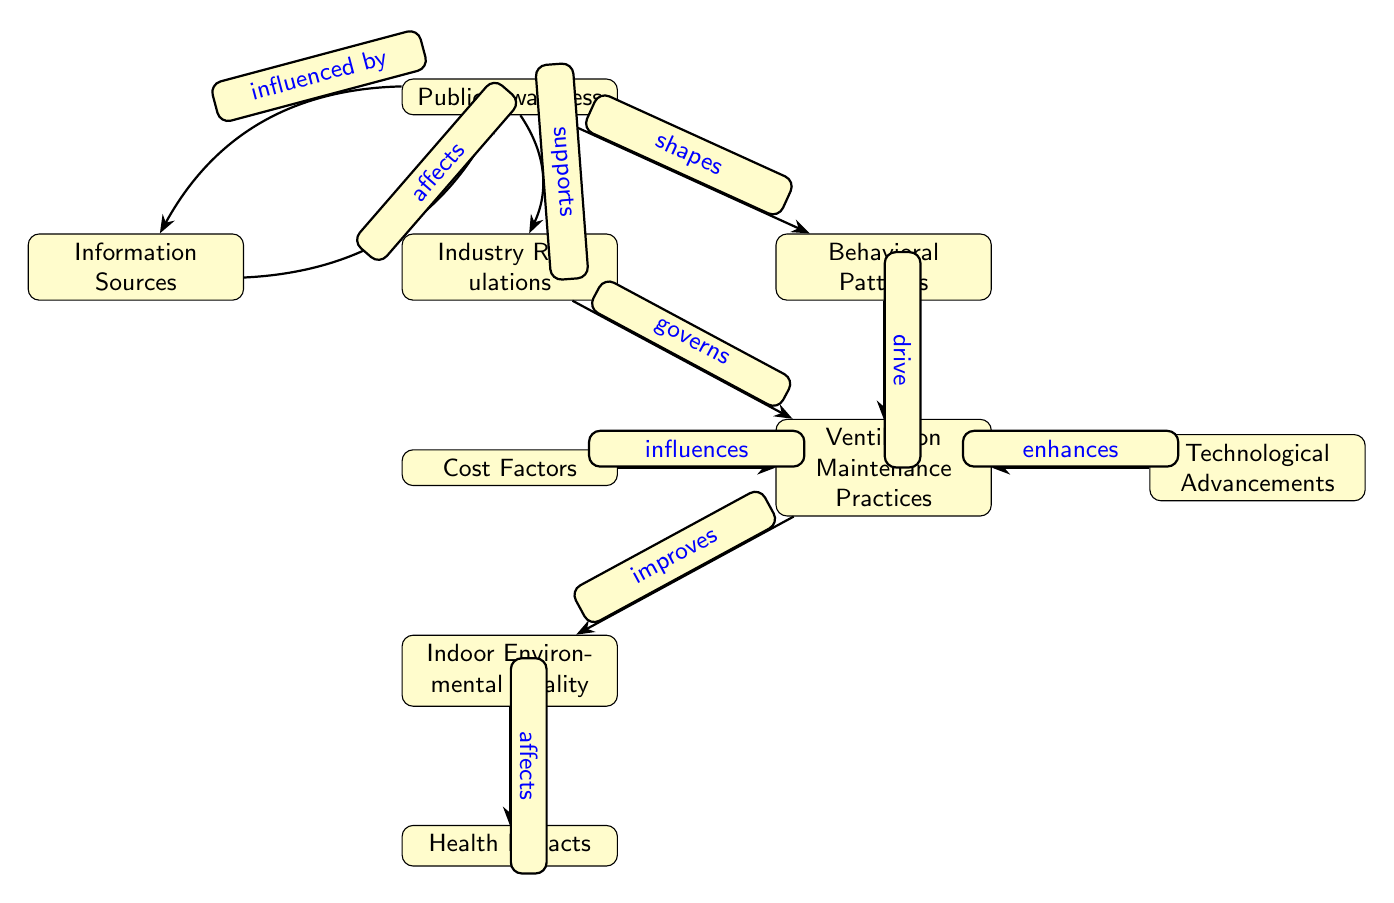What are the two main components that influence Public Awareness? The two main components influencing Public Awareness in the diagram are Information Sources and Industry Regulations. Public Awareness is connected to both these nodes through directed edges indicating influence.
Answer: Information Sources, Industry Regulations How many nodes are depicted in the diagram? The diagram consists of 8 distinct nodes. These nodes represent different concepts related to ventilation maintenance practices and their implications for indoor environmental quality.
Answer: 8 What effect do Behavioral Patterns have on Ventilation Maintenance Practices? Behavioral Patterns directly drive Ventilation Maintenance Practices as indicated by the edge describing this relationship. Therefore, the relationship shows that changes in behavioral patterns will influence how maintenance is performed.
Answer: drive Which node is governed by Industry Regulations? The node governed by Industry Regulations is Ventilation Maintenance Practices, as indicated by the edge connecting these two nodes with the label "governs." This means that regulations put in place by the industry impact how maintenance is conducted.
Answer: Ventilation Maintenance Practices What factors influence Ventilation Maintenance Practices? Ventilation Maintenance Practices are influenced by Cost Factors, Industry Regulations, and Technological Advancements according to the edges leading into the node for maintenance practices, highlighting that various external considerations affect maintenance activities.
Answer: Cost Factors, Industry Regulations, Technological Advancements How does Public Awareness relate to Indoor Environmental Quality? Public Awareness affects Indoor Environmental Quality indirectly through Behavioral Patterns and Ventilation Maintenance Practices. The flow is from Public Awareness to Behavioral Patterns, which drives maintenance practices and ultimately improves indoor environmental quality.
Answer: indirectly What are the Health Impacts dependent on? Health Impacts are dependent on Indoor Environmental Quality, as indicated by the directed edge that shows Indoor Environmental Quality affects Health Impacts. Hence, changes in indoor air quality will influence the health of individuals.
Answer: Indoor Environmental Quality 